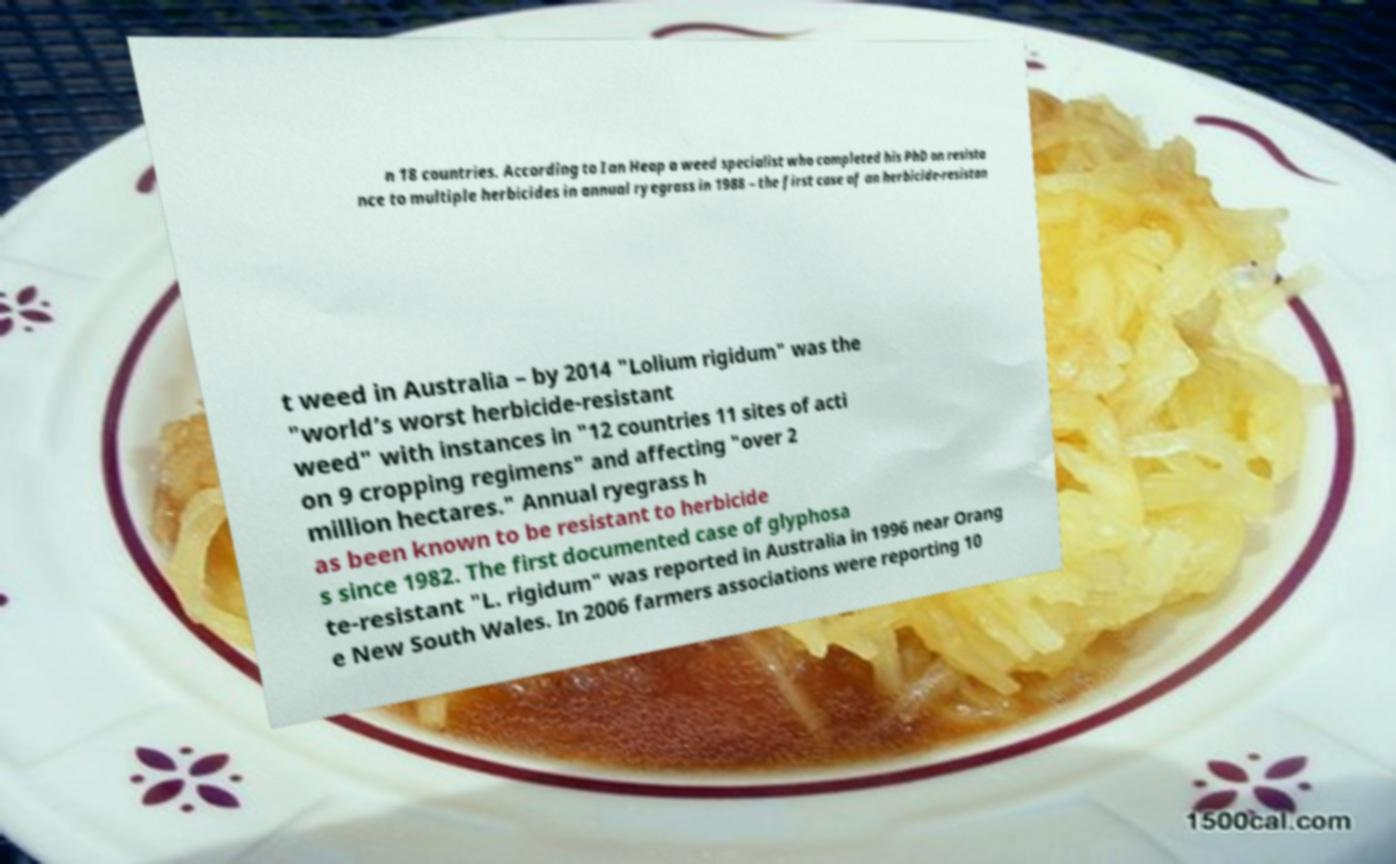Can you accurately transcribe the text from the provided image for me? n 18 countries. According to Ian Heap a weed specialist who completed his PhD on resista nce to multiple herbicides in annual ryegrass in 1988 – the first case of an herbicide-resistan t weed in Australia – by 2014 "Lolium rigidum" was the "world’s worst herbicide-resistant weed" with instances in "12 countries 11 sites of acti on 9 cropping regimens" and affecting "over 2 million hectares." Annual ryegrass h as been known to be resistant to herbicide s since 1982. The first documented case of glyphosa te-resistant "L. rigidum" was reported in Australia in 1996 near Orang e New South Wales. In 2006 farmers associations were reporting 10 